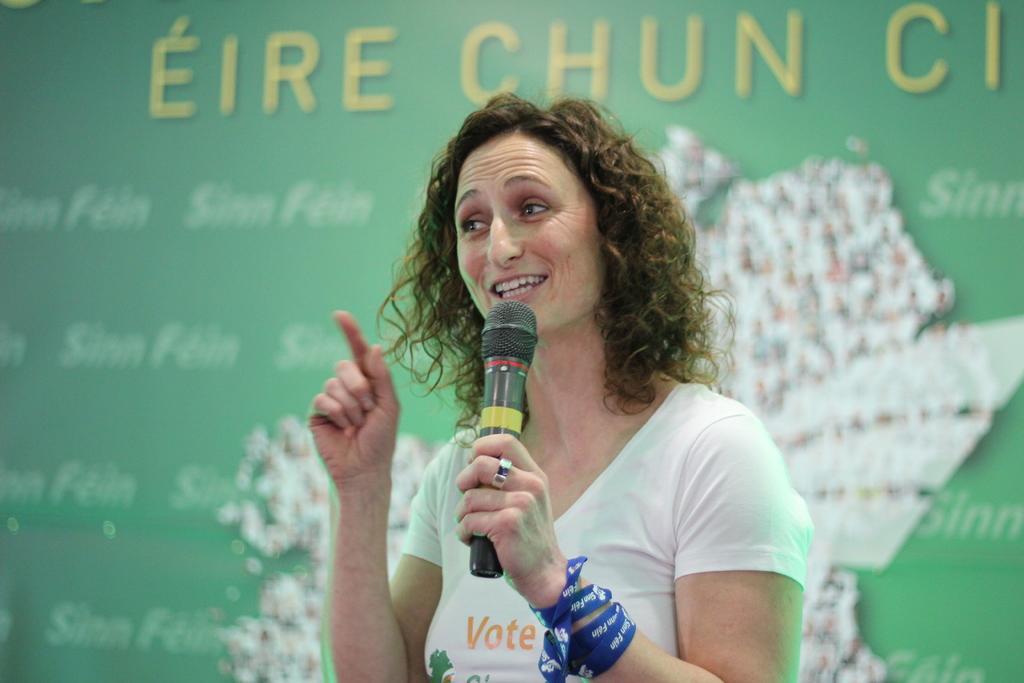Describe this image in one or two sentences. This is the woman standing and talking. She wore white T-shirt and holding mike. At background I can see a green color banner with some words on it. 